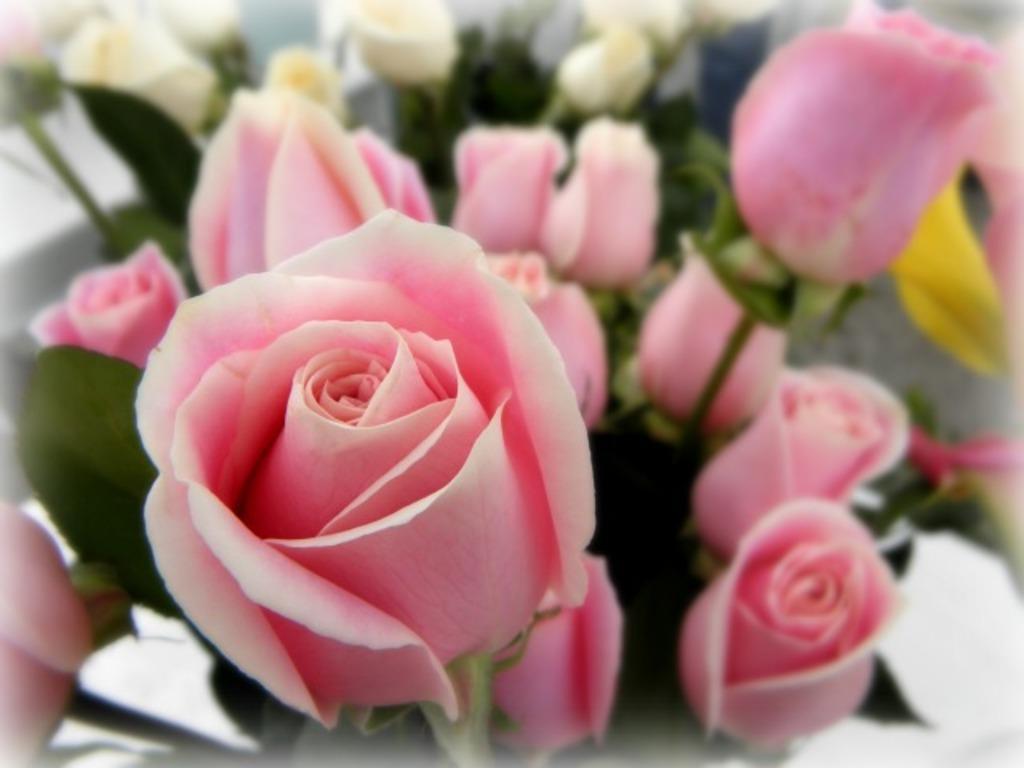Describe this image in one or two sentences. To the front of the image there are pink roses with leaves. Behind them there are white roses with leaves. 